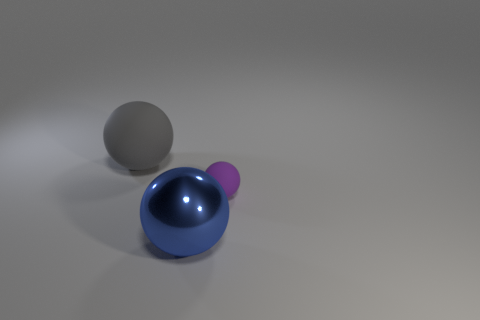Subtract all matte balls. How many balls are left? 1 Subtract all gray balls. How many balls are left? 2 Add 1 big shiny objects. How many big shiny objects exist? 2 Add 1 big matte things. How many objects exist? 4 Subtract 0 purple cylinders. How many objects are left? 3 Subtract 2 balls. How many balls are left? 1 Subtract all cyan spheres. Subtract all blue cylinders. How many spheres are left? 3 Subtract all cyan cubes. How many blue spheres are left? 1 Subtract all big purple things. Subtract all small purple matte balls. How many objects are left? 2 Add 2 small matte things. How many small matte things are left? 3 